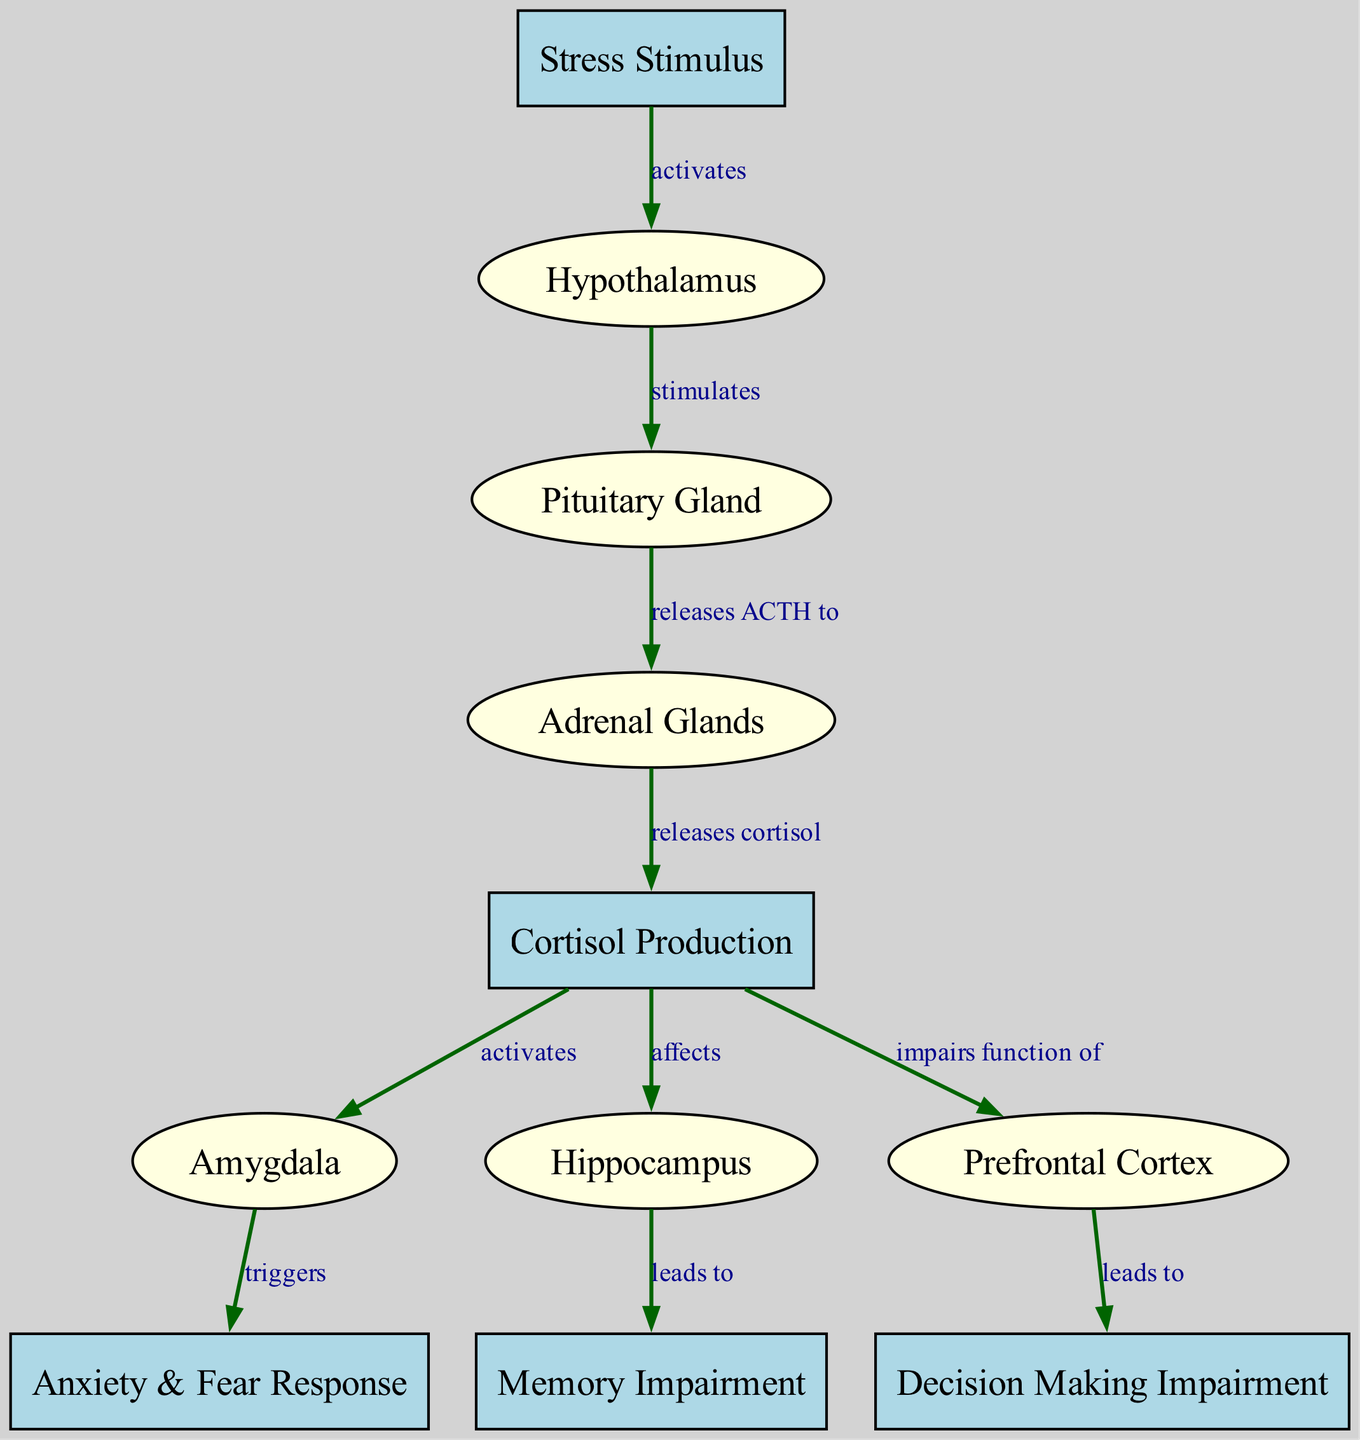What is the starting point of the pathway in the diagram? The pathway starts at the "Stress Stimulus" node, which is the first node in the diagram.
Answer: Stress Stimulus How many overall nodes are present in the diagram? By counting all the nodes listed, there are a total of 11 nodes in the diagram.
Answer: 11 What type of effect does cortisol have on the amygdala? The diagram indicates that cortisol activates the amygdala, leading to anxiety and fear responses.
Answer: activates Which gland releases ACTH according to the diagram? The "Pituitary Gland" is the one that releases ACTH to the adrenal glands as shown in the edges' relationship.
Answer: Pituitary Gland What is the outcome triggered by the amygdala in response to cortisol? The amygdala triggers the "Anxiety & Fear Response" as a consequence of cortisol activation.
Answer: Anxiety & Fear Response What condition does the hippocampus lead to as indicated in the diagram? The hippocampus is shown to lead to "Memory Impairment," demonstrating an impact on memory functions as a result of stress.
Answer: Memory Impairment How does cortisol affect the prefrontal cortex? According to the diagram, cortisol impairs the function of the prefrontal cortex, affecting decision-making processes.
Answer: impairs function of What is released by the adrenal glands in response to ACTH? The adrenal glands release cortisol as shown in the relationship from the Pituitary Gland to the Adrenal Glands.
Answer: cortisol What does the pituitary gland do in this diagram? The pituitary gland stimulates the adrenal glands to release ACTH, which is a crucial step in the stress response pathway.
Answer: stimulates 